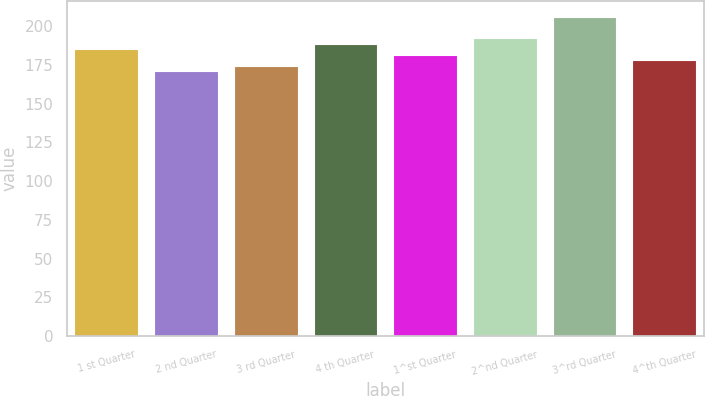Convert chart. <chart><loc_0><loc_0><loc_500><loc_500><bar_chart><fcel>1 st Quarter<fcel>2 nd Quarter<fcel>3 rd Quarter<fcel>4 th Quarter<fcel>1^st Quarter<fcel>2^nd Quarter<fcel>3^rd Quarter<fcel>4^th Quarter<nl><fcel>184.99<fcel>170.99<fcel>174.49<fcel>188.49<fcel>181.49<fcel>191.99<fcel>206.02<fcel>177.99<nl></chart> 